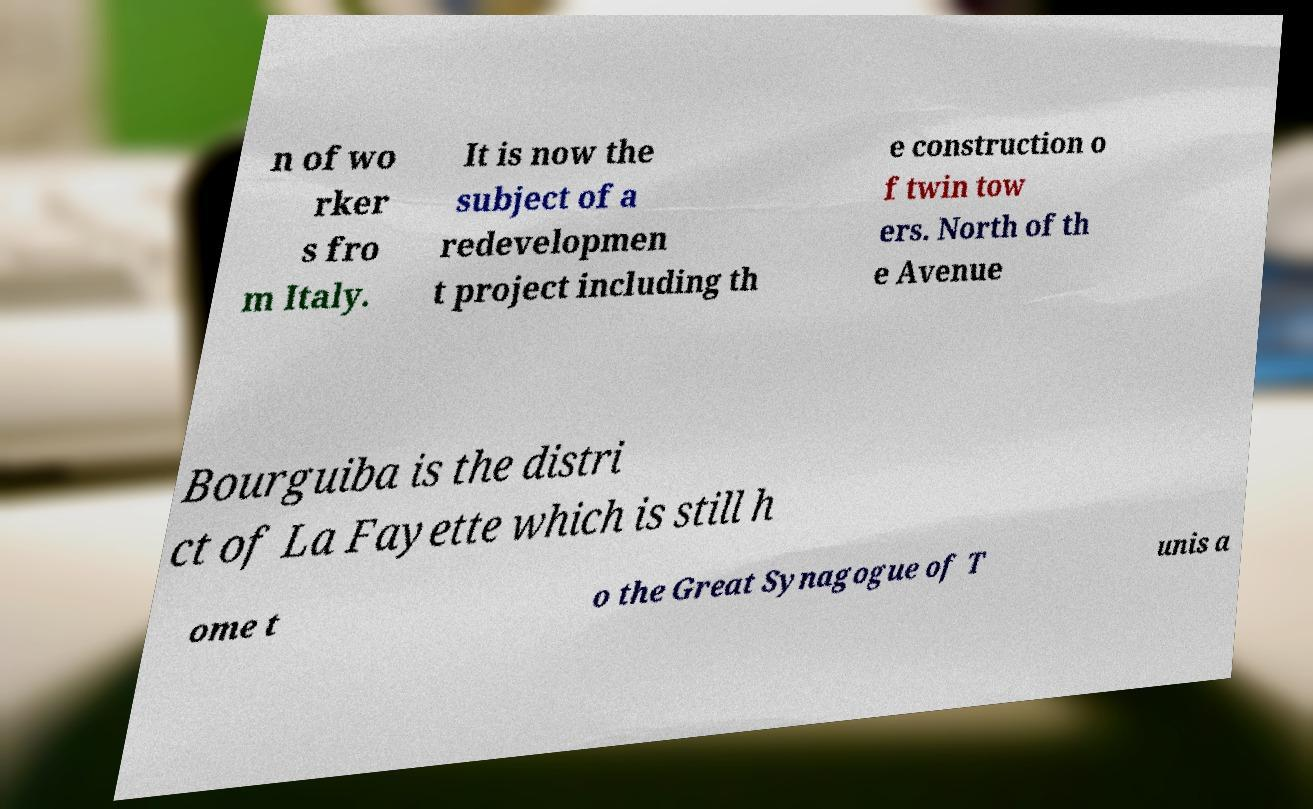What messages or text are displayed in this image? I need them in a readable, typed format. n of wo rker s fro m Italy. It is now the subject of a redevelopmen t project including th e construction o f twin tow ers. North of th e Avenue Bourguiba is the distri ct of La Fayette which is still h ome t o the Great Synagogue of T unis a 